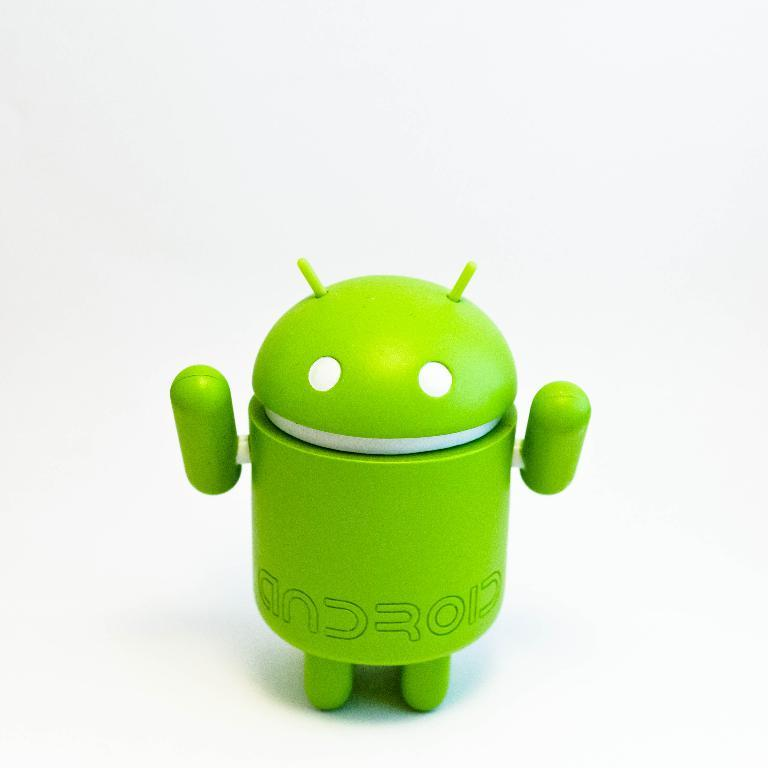<image>
Present a compact description of the photo's key features. A small green figure with android printed across his lower waist stands with his hands up. 